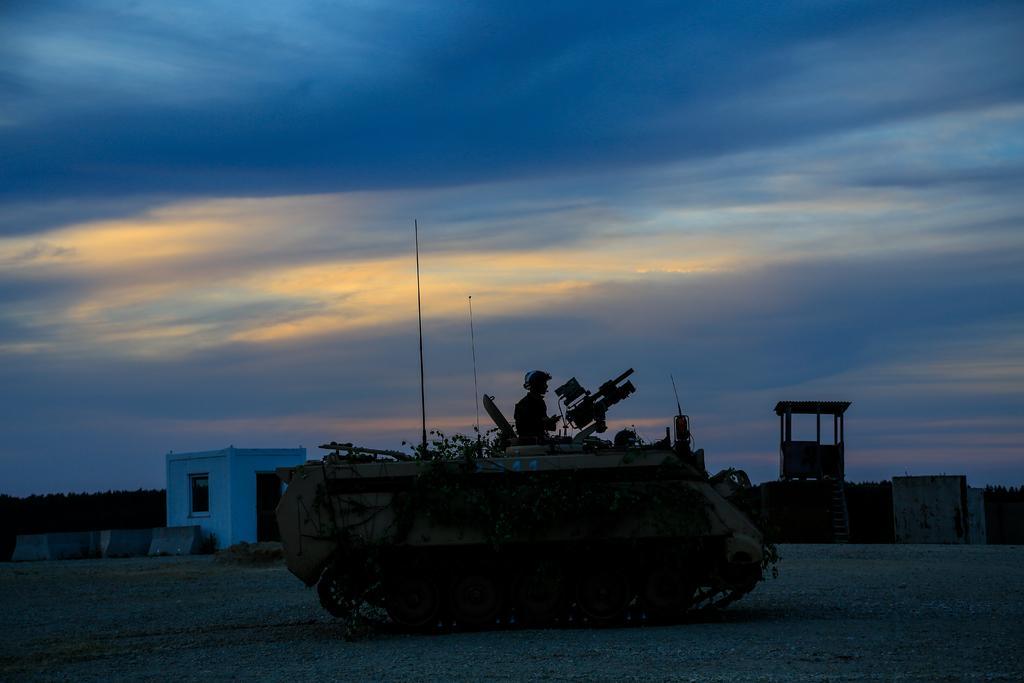Describe this image in one or two sentences. In the foreground of the image we can see a person on a vehicle with poles and a gun is parked on the ground. In the background, we can see a building with window, door, a shed and a container placed on the ground, groups of trees and the cloudy sky. 